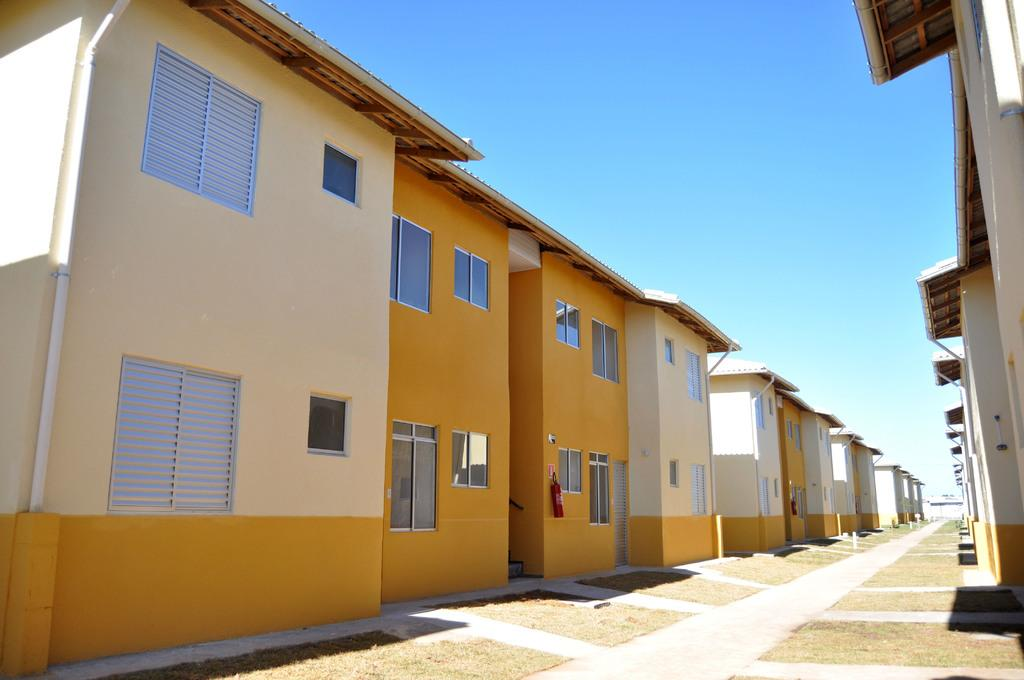What type of structures are located on the right side of the image? There are houses on the right side of the image. What colors are the houses on the right side? The houses on the right side have orange and cream colors. What type of structures are located on the left side of the image? There are houses on the left side of the image. What colors are the houses on the left side? The houses on the left side have orange and cream colors. What is in the middle of the houses? There is a road in the middle of the houses. What is the opinion of the office building in the image? There is no office building present in the image. What is the birth date of the person who designed the houses in the image? The provided facts do not include any information about the designer or their birth date. 